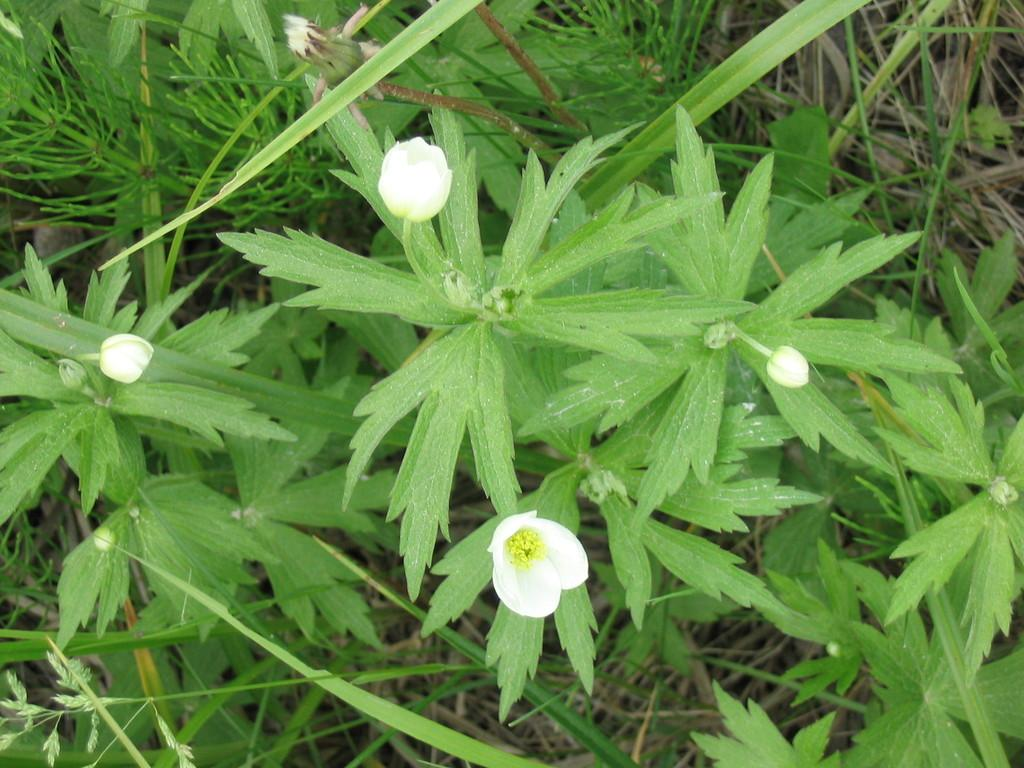What type of plants are present in the image? There are plants with flowers and flower buds in the image. Can you describe the flowers on the plants? The flowers on the plants are visible in the image. What is located at the bottom of the image? There is grass at the bottom of the image. How many divisions are present in the lock featured in the image? There is no lock present in the image; it features plants with flowers and flower buds, as well as grass at the bottom. 